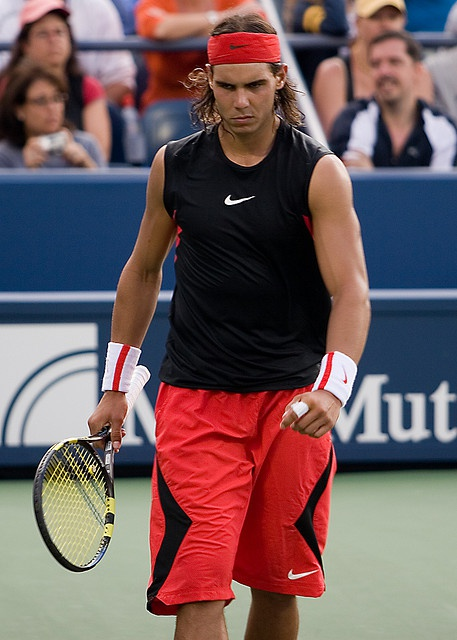Describe the objects in this image and their specific colors. I can see people in lavender, black, and brown tones, people in lavender, black, brown, and gray tones, tennis racket in lavender, black, khaki, darkgray, and tan tones, people in lavender, maroon, gray, lightpink, and brown tones, and people in lavender, black, brown, lightpink, and maroon tones in this image. 